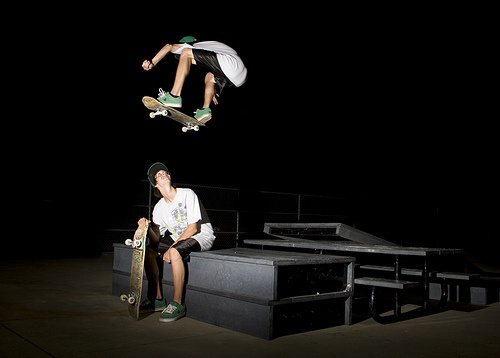Describe the objects in this image and their specific colors. I can see bench in black and gray tones, people in black, white, tan, and gray tones, bench in black and gray tones, people in black, lightgray, tan, and darkgray tones, and skateboard in black, gray, and tan tones in this image. 